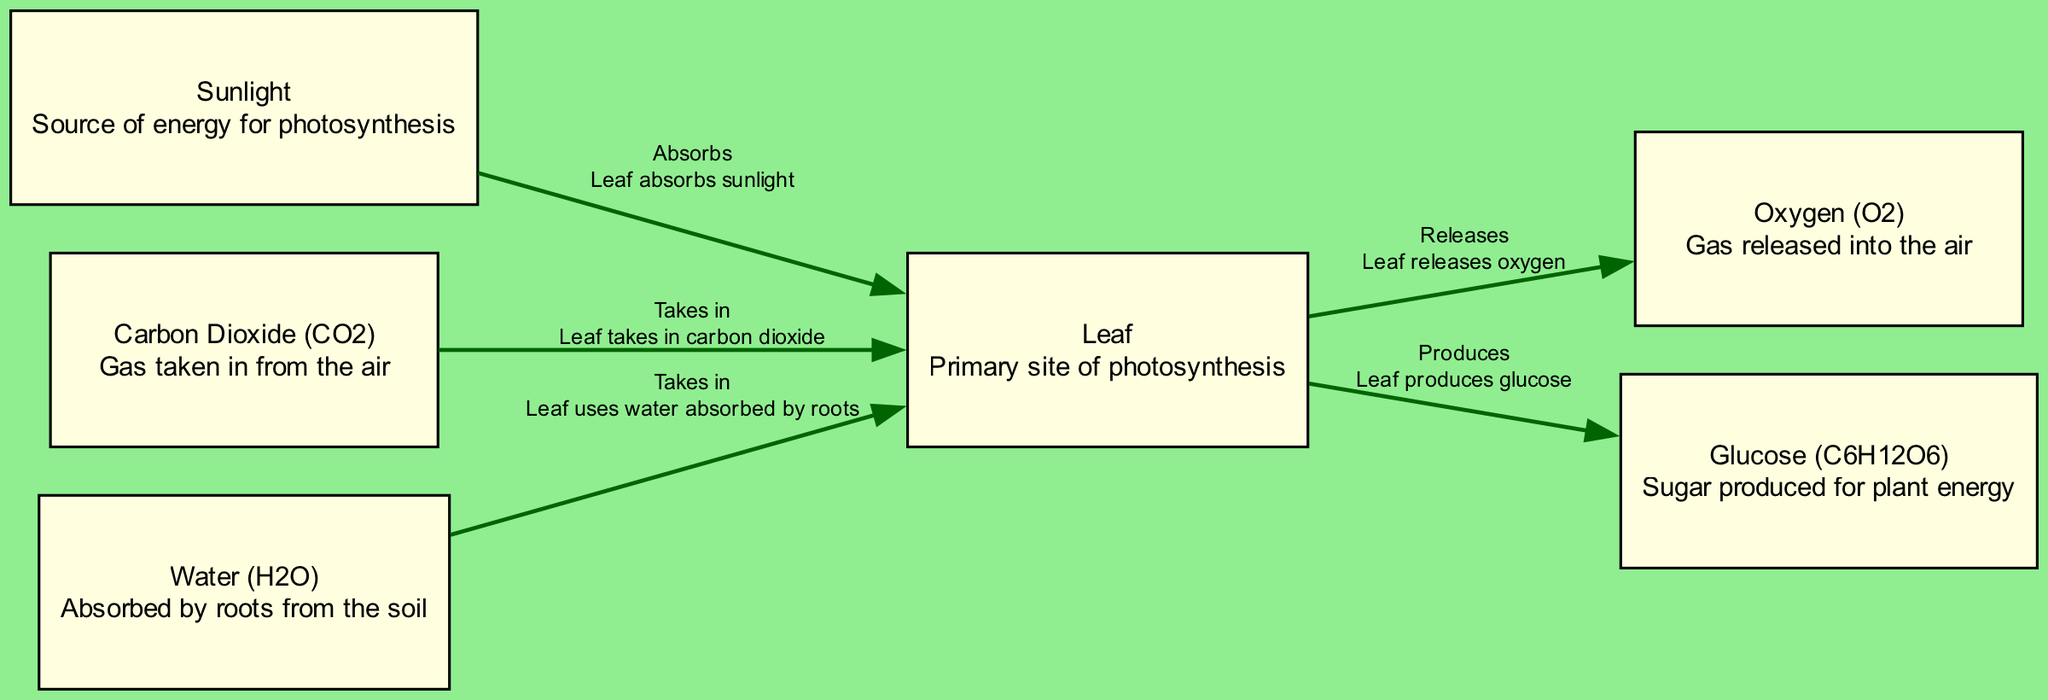What is the primary site of photosynthesis? The diagram indicates that "Leaf" is labeled as the primary site of photosynthesis. This is explicitly stated in the node description near the center of the diagram.
Answer: Leaf How many nodes are present in the diagram? By counting the number of unique sections shown in the diagram, we find there are 6 nodes: Sunlight, Leaf, Carbon Dioxide, Water, Oxygen, and Glucose.
Answer: 6 What gas is released into the air during photosynthesis? Based on the diagram, "Oxygen" is indicated as the gas that is released during the photosynthesis process. This information is directly mentioned in the description of the corresponding node.
Answer: Oxygen What does the leaf absorb from sunlight? The diagram specifies that the leaf "absorbs" sunlight, meaning it takes in sunlight as part of the photosynthesis process, which is crucial for energy production in plants.
Answer: Sunlight What substance does the leaf take in from the air? In the diagram, the relationship indicates that the leaf "takes in" Carbon Dioxide from the air as part of the photosynthesis cycle. This is a direct connection shown in the edges section.
Answer: Carbon Dioxide Which process is responsible for glucose production in plants? The flow in the diagram shows that the leaf "produces" glucose as a result of photosynthesis, which occurs when sunlight, carbon dioxide, and water interact in the leaf. This defines the overall process.
Answer: Photosynthesis What do roots absorb from the soil? The diagram indicates that the roots absorb "Water," which is utilized in the leaf for the photosynthesis process. This is explicitly described in the relationship between the nodes.
Answer: Water What is the product of photosynthesis used for plant energy? The diagram shows that "Glucose" is produced as a byproduct of photosynthesis and is primarily used for energy by the plant, as indicated in the description of the glucose node.
Answer: Glucose What connects the leaf and oxygen in the diagram? The edge in the diagram labeled "Releases" indicates that the leaf releases oxygen during the photosynthesis process, establishing a clear connection between these two nodes.
Answer: Releases 